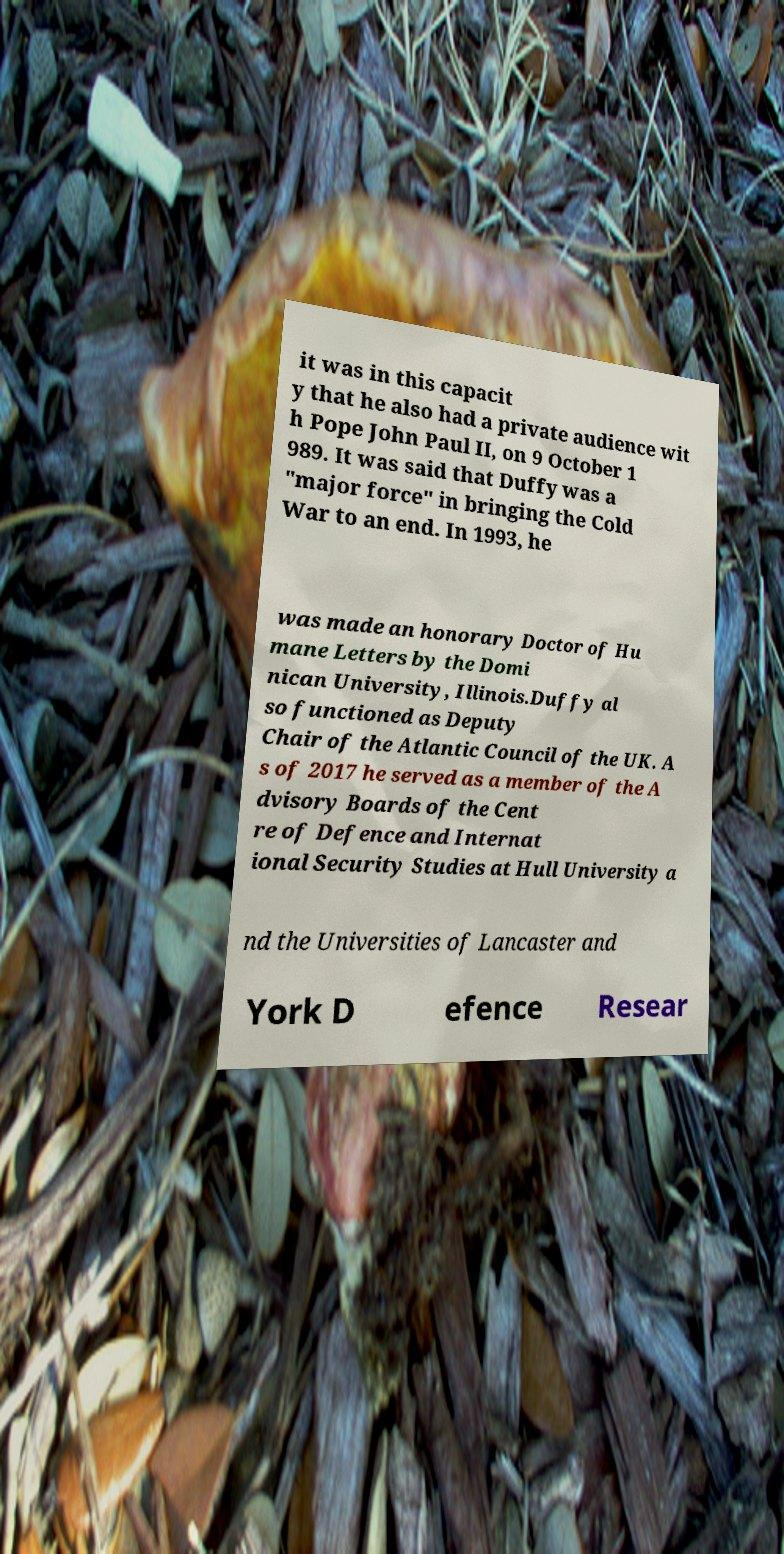There's text embedded in this image that I need extracted. Can you transcribe it verbatim? it was in this capacit y that he also had a private audience wit h Pope John Paul II, on 9 October 1 989. It was said that Duffy was a "major force" in bringing the Cold War to an end. In 1993, he was made an honorary Doctor of Hu mane Letters by the Domi nican University, Illinois.Duffy al so functioned as Deputy Chair of the Atlantic Council of the UK. A s of 2017 he served as a member of the A dvisory Boards of the Cent re of Defence and Internat ional Security Studies at Hull University a nd the Universities of Lancaster and York D efence Resear 